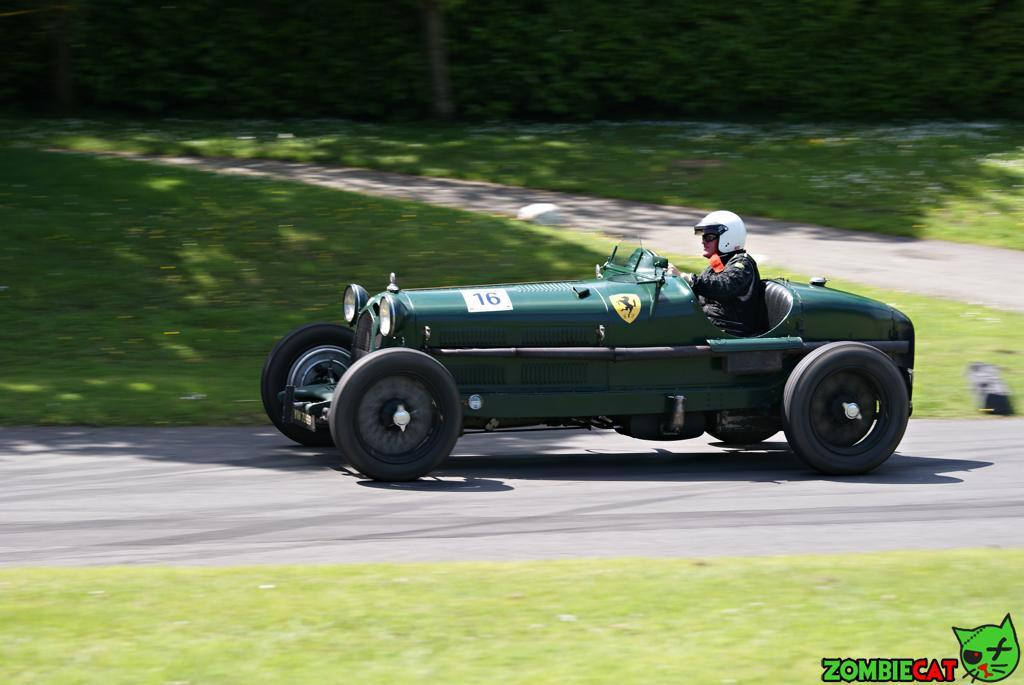What is the main subject of the image? The main subject of the image is a car. Can you describe the person in the image? There is a person wearing a helmet in the image. What type of environment is visible in the image? There is grass visible in the image. What is present at the bottom of the image? There is written text at the bottom of the image. How many branches can be seen growing from the person's feet in the image? There are no branches visible in the image, and the person's feet are not mentioned in the provided facts. 